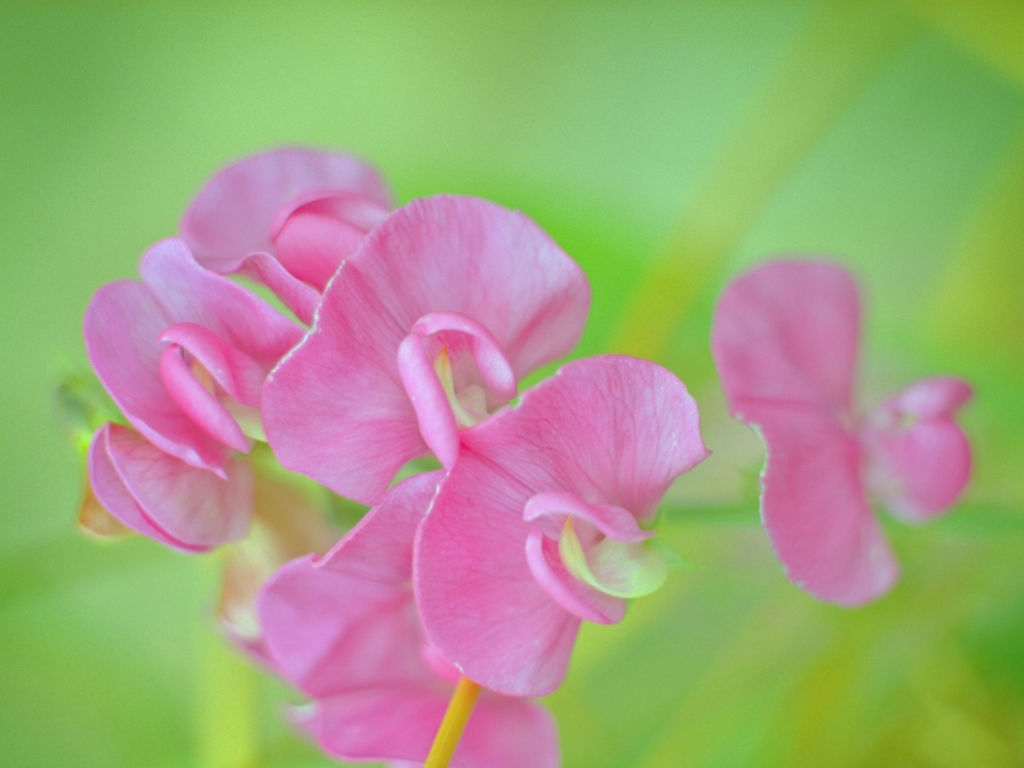What can you infer about the type of flower shown in the image? The flower in the image appears to be a type of sweet pea. Its distinctive ruffled pink petals and the way they grow in clusters are characteristic of this fragrant flowering plant, often found in cottage gardens and known for symbolizing pleasure or blissful pleasure. How does the choice of depth of field affect the photograph? The shallow depth of field brings attention to the flowers in the foreground, creating a soft backdrop that helps the subject to stand out. This technique emphasizes the delicate textures of the petals and conveys an intimate perspective on the beauty of the flower. 